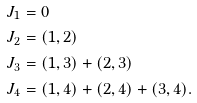<formula> <loc_0><loc_0><loc_500><loc_500>J _ { 1 } & = 0 \\ J _ { 2 } & = ( 1 , 2 ) \\ J _ { 3 } & = ( 1 , 3 ) + ( 2 , 3 ) \\ J _ { 4 } & = ( 1 , 4 ) + ( 2 , 4 ) + ( 3 , 4 ) .</formula> 